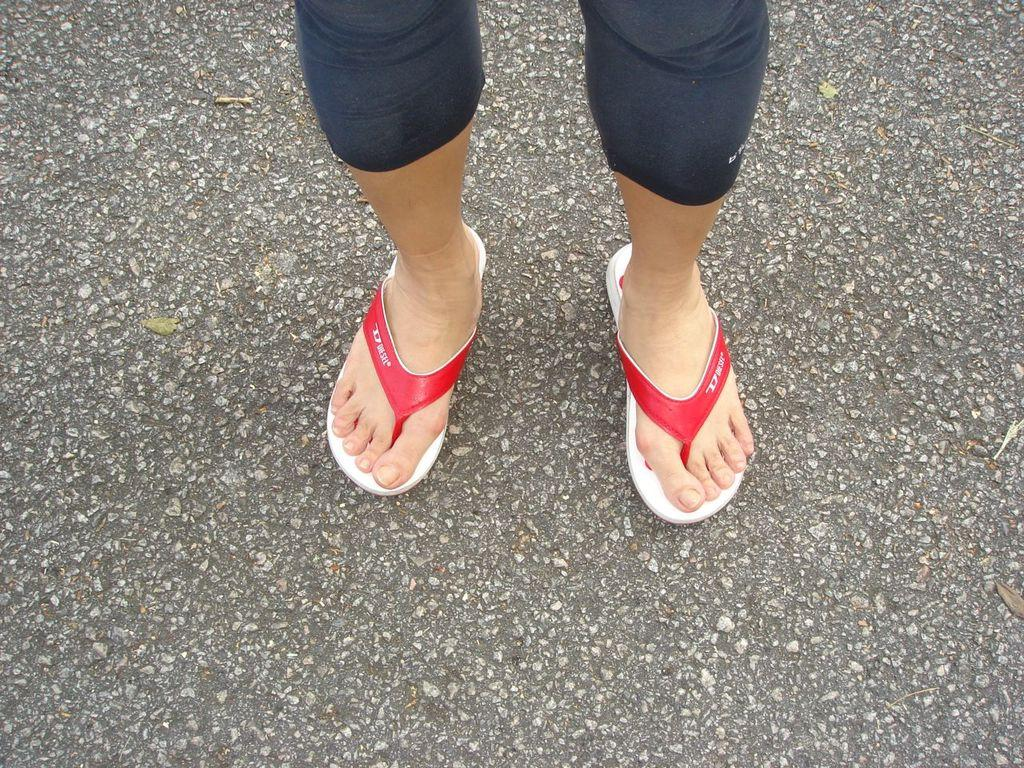What is the main subject of the image? The main subject of the image is a human. Can you describe the location of the human in the image? The human is standing on the road. What type of blade is being used by the human in the image? There is no blade present in the image; the human is simply standing on the road. 